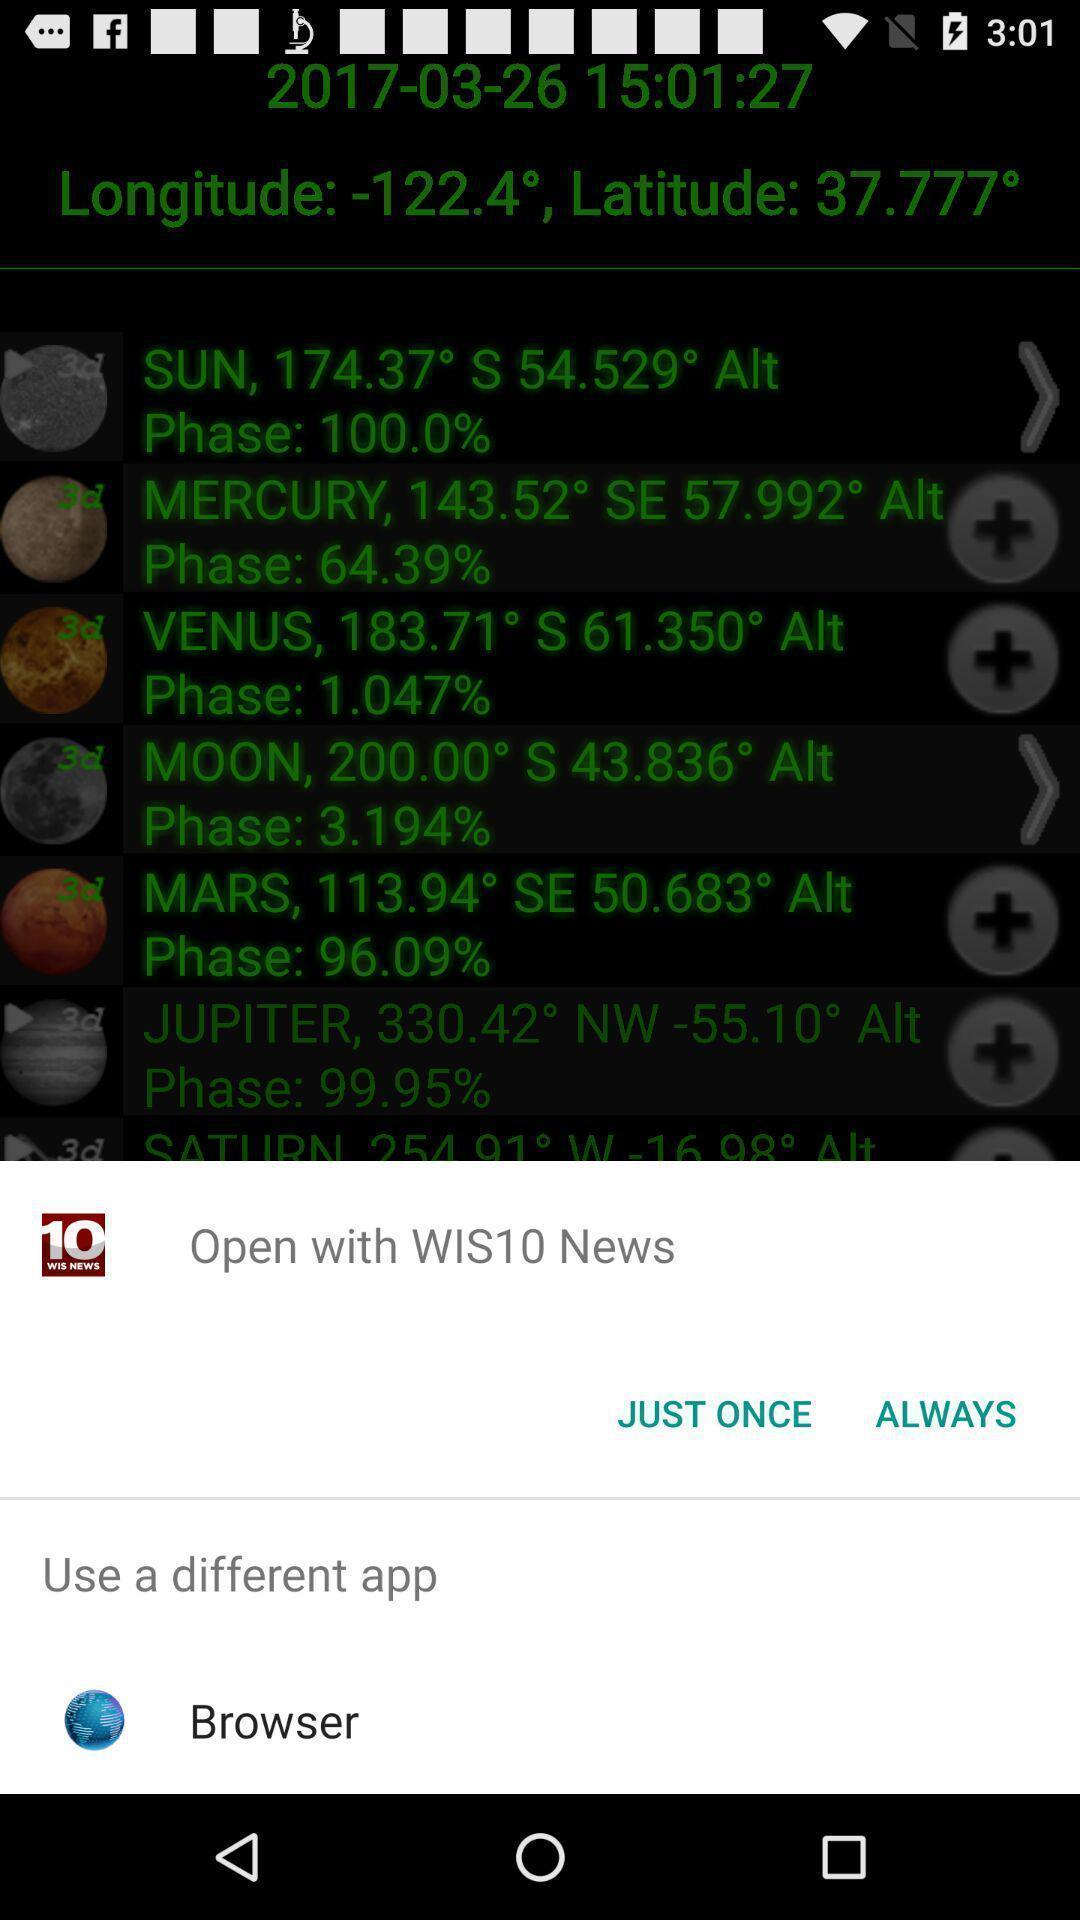What is the overall content of this screenshot? Pop-up showing multiple options. 